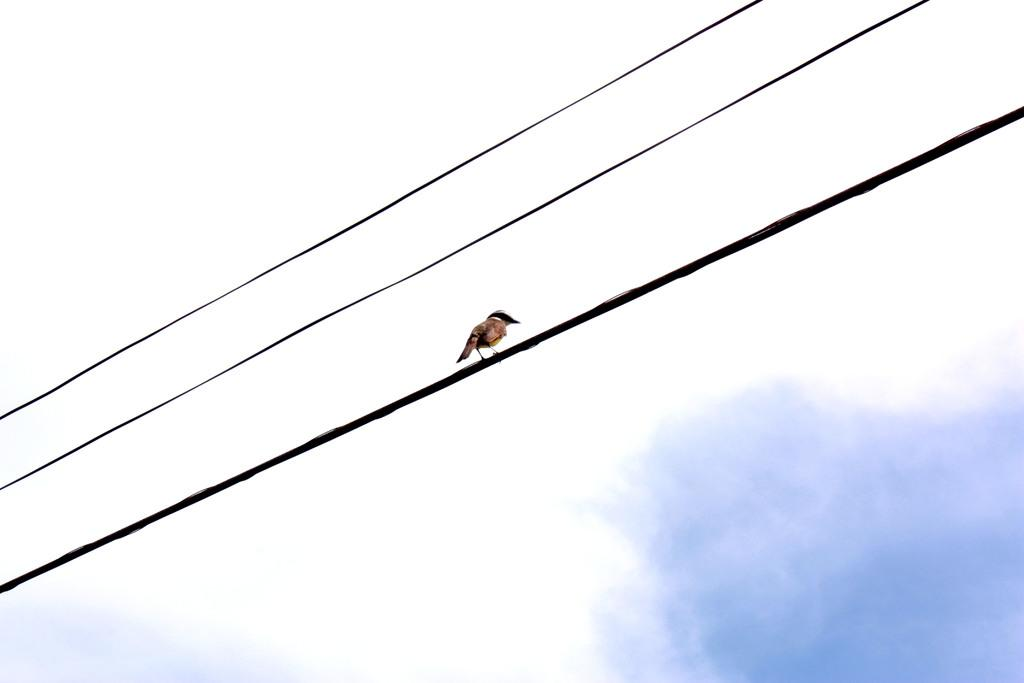What is the condition of the sky in the image? The sky in the image is cloudy. What type of man-made structures can be seen in the image? Electrical cables are visible in the image. Is there any wildlife present in the image? Yes, a bird is sitting on one of the electrical cables. What type of banana is being crushed by the electrical cables in the image? There is no banana present in the image, and the electrical cables are not crushing anything. 